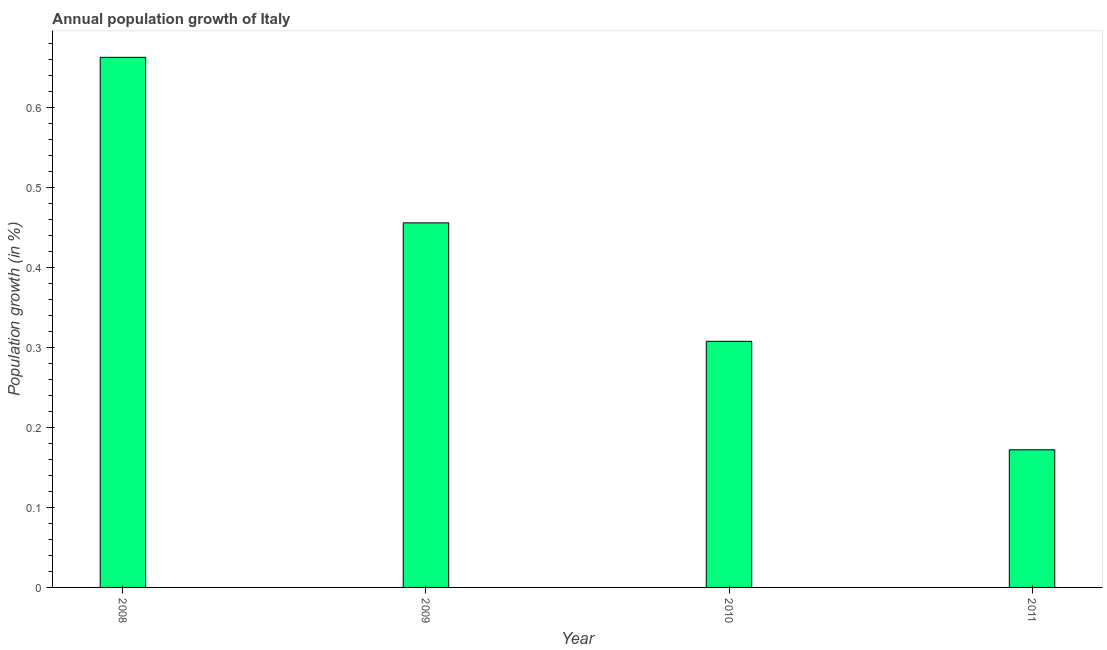Does the graph contain any zero values?
Keep it short and to the point. No. Does the graph contain grids?
Keep it short and to the point. No. What is the title of the graph?
Keep it short and to the point. Annual population growth of Italy. What is the label or title of the Y-axis?
Offer a very short reply. Population growth (in %). What is the population growth in 2011?
Give a very brief answer. 0.17. Across all years, what is the maximum population growth?
Your answer should be compact. 0.66. Across all years, what is the minimum population growth?
Your response must be concise. 0.17. In which year was the population growth maximum?
Provide a succinct answer. 2008. In which year was the population growth minimum?
Keep it short and to the point. 2011. What is the sum of the population growth?
Your answer should be very brief. 1.6. What is the difference between the population growth in 2009 and 2011?
Provide a succinct answer. 0.28. What is the average population growth per year?
Your response must be concise. 0.4. What is the median population growth?
Provide a short and direct response. 0.38. In how many years, is the population growth greater than 0.5 %?
Provide a short and direct response. 1. What is the ratio of the population growth in 2009 to that in 2011?
Your answer should be very brief. 2.65. What is the difference between the highest and the second highest population growth?
Ensure brevity in your answer.  0.21. What is the difference between the highest and the lowest population growth?
Ensure brevity in your answer.  0.49. In how many years, is the population growth greater than the average population growth taken over all years?
Offer a very short reply. 2. How many bars are there?
Offer a terse response. 4. How many years are there in the graph?
Provide a succinct answer. 4. What is the difference between two consecutive major ticks on the Y-axis?
Make the answer very short. 0.1. Are the values on the major ticks of Y-axis written in scientific E-notation?
Provide a succinct answer. No. What is the Population growth (in %) of 2008?
Your answer should be very brief. 0.66. What is the Population growth (in %) of 2009?
Your response must be concise. 0.46. What is the Population growth (in %) of 2010?
Your answer should be very brief. 0.31. What is the Population growth (in %) of 2011?
Keep it short and to the point. 0.17. What is the difference between the Population growth (in %) in 2008 and 2009?
Offer a terse response. 0.21. What is the difference between the Population growth (in %) in 2008 and 2010?
Make the answer very short. 0.35. What is the difference between the Population growth (in %) in 2008 and 2011?
Ensure brevity in your answer.  0.49. What is the difference between the Population growth (in %) in 2009 and 2010?
Provide a short and direct response. 0.15. What is the difference between the Population growth (in %) in 2009 and 2011?
Give a very brief answer. 0.28. What is the difference between the Population growth (in %) in 2010 and 2011?
Ensure brevity in your answer.  0.14. What is the ratio of the Population growth (in %) in 2008 to that in 2009?
Offer a terse response. 1.45. What is the ratio of the Population growth (in %) in 2008 to that in 2010?
Provide a succinct answer. 2.15. What is the ratio of the Population growth (in %) in 2008 to that in 2011?
Ensure brevity in your answer.  3.85. What is the ratio of the Population growth (in %) in 2009 to that in 2010?
Keep it short and to the point. 1.48. What is the ratio of the Population growth (in %) in 2009 to that in 2011?
Make the answer very short. 2.65. What is the ratio of the Population growth (in %) in 2010 to that in 2011?
Keep it short and to the point. 1.79. 